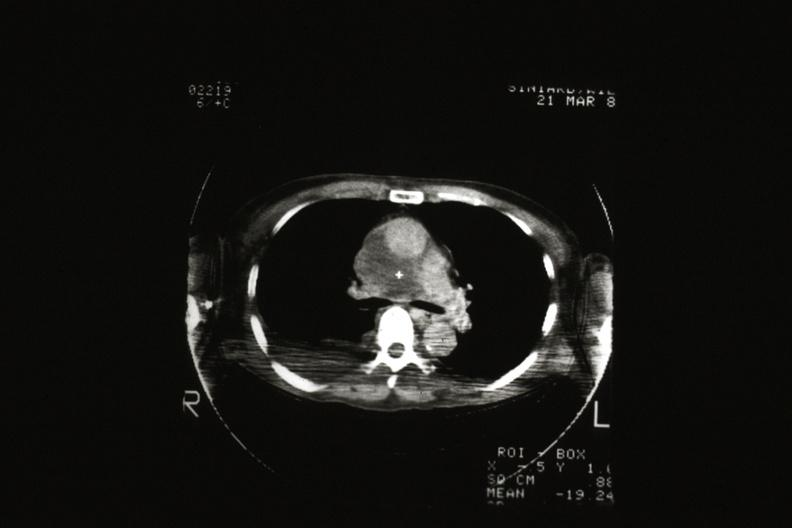what is present?
Answer the question using a single word or phrase. Thymus 